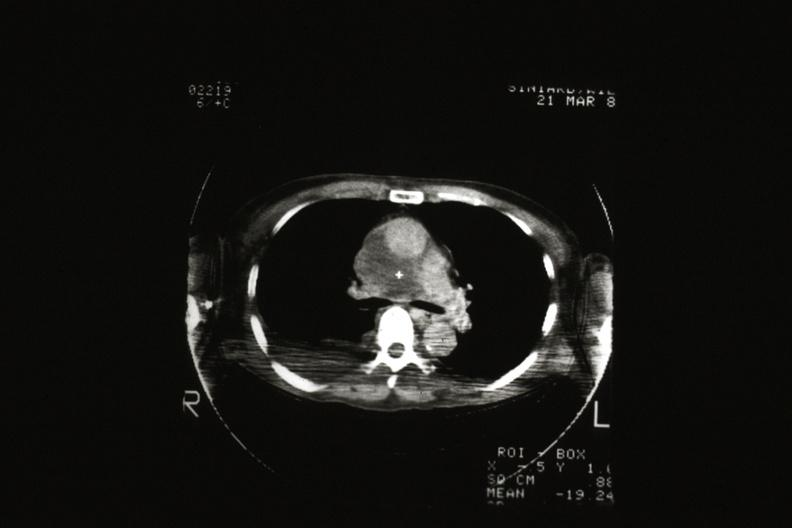what is present?
Answer the question using a single word or phrase. Thymus 